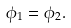<formula> <loc_0><loc_0><loc_500><loc_500>\phi _ { 1 } = \phi _ { 2 } .</formula> 